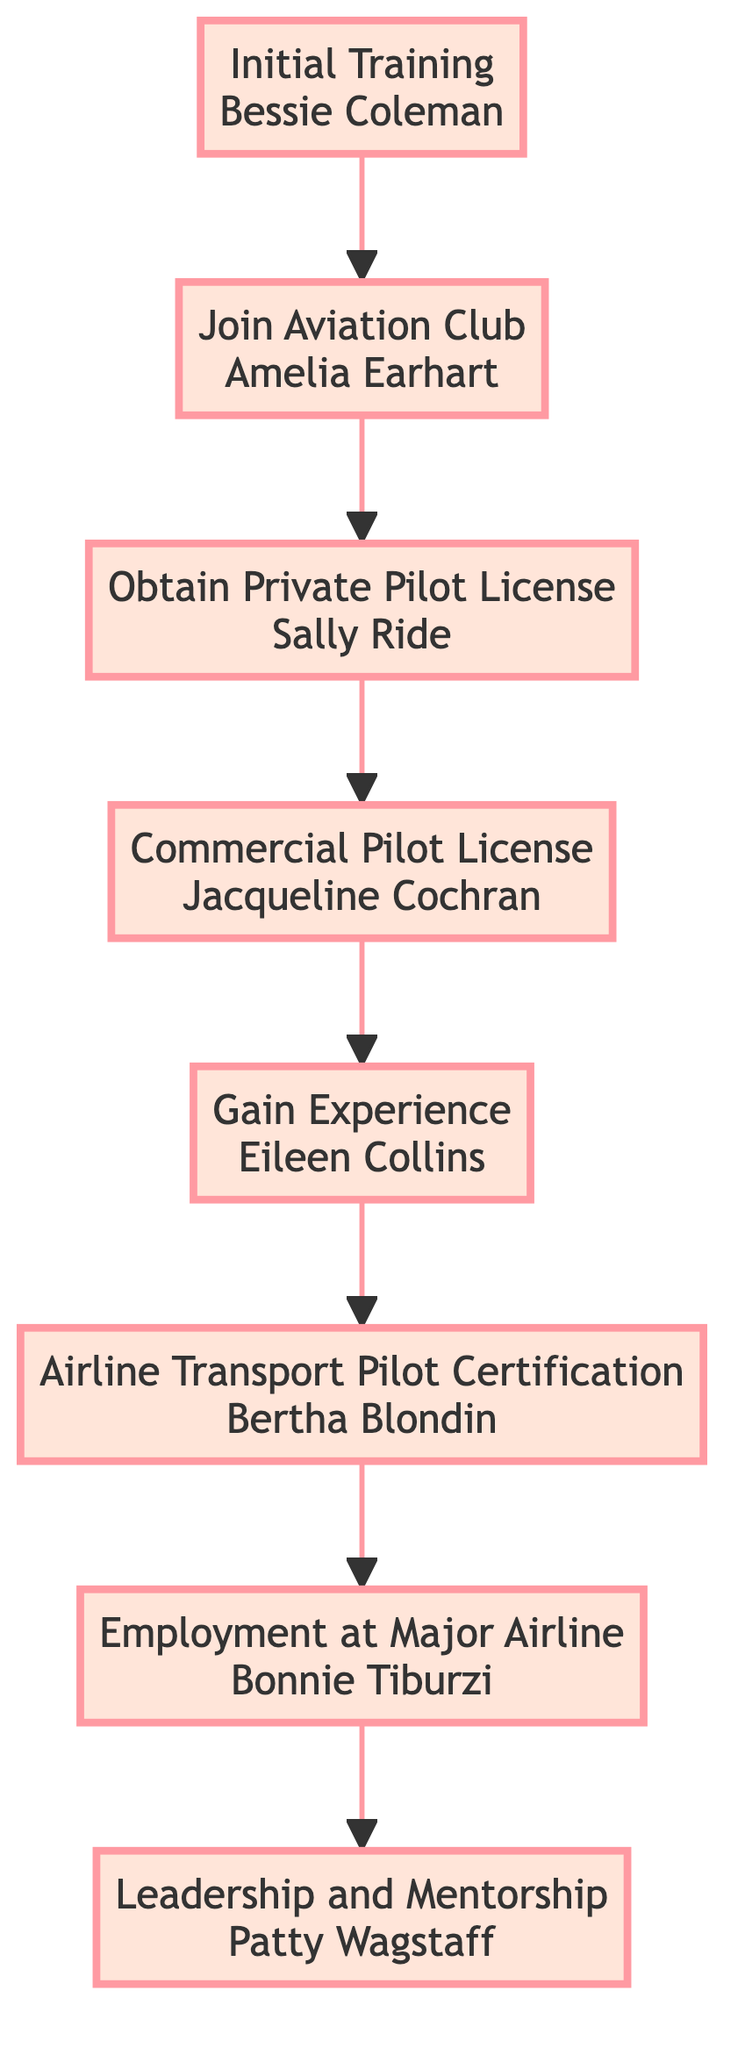What is the first step in the career advancement flow? The first step in the diagram is labeled "Initial Training" and is connected to the notable figure Bessie Coleman.
Answer: Initial Training Who is associated with obtaining a Private Pilot License? The node for "Obtain Private Pilot License" cites Sally Ride as the notable figure associated with this achievement.
Answer: Sally Ride How many notable women in aviation are highlighted in this diagram? Counting each of the elements (Initial Training, Join Aviation Club, etc.), there are a total of eight notable women highlighted in the diagram.
Answer: Eight What achievement is linked to the Commercial Pilot License step? The step labeled "Commercial Pilot License" is associated with the achievement "First woman to break the sound barrier," attributed to Jacqueline Cochran.
Answer: First woman to break the sound barrier Which step follows "Gain Experience"? The node following "Gain Experience" is "Airline Transport Pilot Certification," indicating the next step in the career advancement.
Answer: Airline Transport Pilot Certification What is the significance of the "Leadership and Mentorship" step in the flow? "Leadership and Mentorship" is the final step that highlights the achievements of Patty Wagstaff, emphasizing the importance of leading and mentoring in aviation careers.
Answer: Leadership and Mentorship Which figure achieved the first female captain of a major U.S. airline? The achievement of "First female captain of a major U.S. airline" is linked to the step "Airline Transport Pilot Certification," specifically noting Bertha Blondin.
Answer: Bertha Blondin If a woman completes the "Commercial Pilot License," what is her next step according to the flow? After completing the "Commercial Pilot License," the next step is to "Gain Experience," continuing her career advancement in aviation.
Answer: Gain Experience 